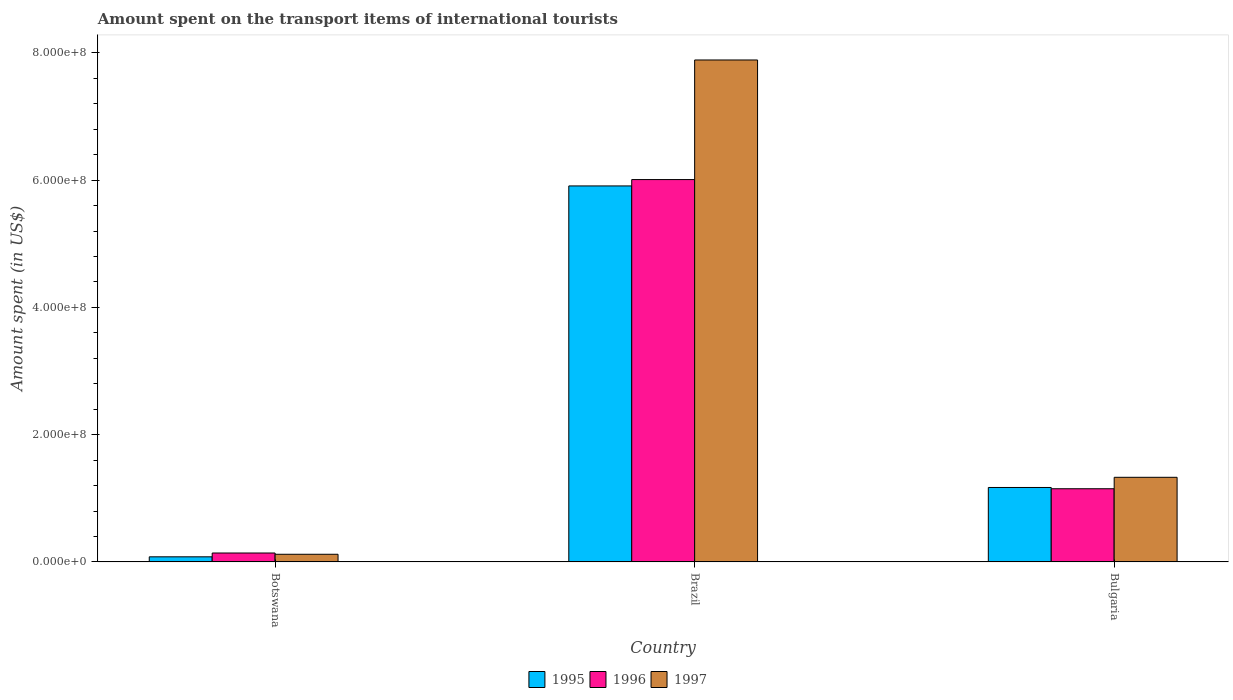How many groups of bars are there?
Offer a terse response. 3. Are the number of bars on each tick of the X-axis equal?
Offer a very short reply. Yes. What is the label of the 2nd group of bars from the left?
Give a very brief answer. Brazil. What is the amount spent on the transport items of international tourists in 1995 in Bulgaria?
Your response must be concise. 1.17e+08. Across all countries, what is the maximum amount spent on the transport items of international tourists in 1995?
Make the answer very short. 5.91e+08. In which country was the amount spent on the transport items of international tourists in 1995 maximum?
Offer a very short reply. Brazil. In which country was the amount spent on the transport items of international tourists in 1996 minimum?
Ensure brevity in your answer.  Botswana. What is the total amount spent on the transport items of international tourists in 1996 in the graph?
Your answer should be very brief. 7.30e+08. What is the difference between the amount spent on the transport items of international tourists in 1997 in Botswana and that in Brazil?
Provide a short and direct response. -7.77e+08. What is the difference between the amount spent on the transport items of international tourists in 1996 in Botswana and the amount spent on the transport items of international tourists in 1997 in Brazil?
Your answer should be very brief. -7.75e+08. What is the average amount spent on the transport items of international tourists in 1995 per country?
Provide a succinct answer. 2.39e+08. What is the difference between the amount spent on the transport items of international tourists of/in 1995 and amount spent on the transport items of international tourists of/in 1997 in Bulgaria?
Provide a short and direct response. -1.60e+07. In how many countries, is the amount spent on the transport items of international tourists in 1997 greater than 520000000 US$?
Your answer should be very brief. 1. What is the ratio of the amount spent on the transport items of international tourists in 1997 in Brazil to that in Bulgaria?
Provide a short and direct response. 5.93. Is the amount spent on the transport items of international tourists in 1996 in Botswana less than that in Bulgaria?
Make the answer very short. Yes. Is the difference between the amount spent on the transport items of international tourists in 1995 in Botswana and Bulgaria greater than the difference between the amount spent on the transport items of international tourists in 1997 in Botswana and Bulgaria?
Give a very brief answer. Yes. What is the difference between the highest and the second highest amount spent on the transport items of international tourists in 1995?
Your answer should be compact. 5.83e+08. What is the difference between the highest and the lowest amount spent on the transport items of international tourists in 1997?
Your answer should be very brief. 7.77e+08. What does the 1st bar from the right in Botswana represents?
Provide a short and direct response. 1997. How many bars are there?
Ensure brevity in your answer.  9. Are all the bars in the graph horizontal?
Provide a short and direct response. No. How many countries are there in the graph?
Your answer should be very brief. 3. What is the difference between two consecutive major ticks on the Y-axis?
Offer a very short reply. 2.00e+08. Are the values on the major ticks of Y-axis written in scientific E-notation?
Make the answer very short. Yes. How many legend labels are there?
Your answer should be very brief. 3. How are the legend labels stacked?
Make the answer very short. Horizontal. What is the title of the graph?
Keep it short and to the point. Amount spent on the transport items of international tourists. What is the label or title of the X-axis?
Your answer should be very brief. Country. What is the label or title of the Y-axis?
Your response must be concise. Amount spent (in US$). What is the Amount spent (in US$) in 1995 in Botswana?
Ensure brevity in your answer.  8.00e+06. What is the Amount spent (in US$) in 1996 in Botswana?
Your response must be concise. 1.40e+07. What is the Amount spent (in US$) in 1995 in Brazil?
Offer a terse response. 5.91e+08. What is the Amount spent (in US$) of 1996 in Brazil?
Ensure brevity in your answer.  6.01e+08. What is the Amount spent (in US$) in 1997 in Brazil?
Your answer should be compact. 7.89e+08. What is the Amount spent (in US$) in 1995 in Bulgaria?
Ensure brevity in your answer.  1.17e+08. What is the Amount spent (in US$) in 1996 in Bulgaria?
Make the answer very short. 1.15e+08. What is the Amount spent (in US$) in 1997 in Bulgaria?
Your answer should be compact. 1.33e+08. Across all countries, what is the maximum Amount spent (in US$) of 1995?
Give a very brief answer. 5.91e+08. Across all countries, what is the maximum Amount spent (in US$) of 1996?
Keep it short and to the point. 6.01e+08. Across all countries, what is the maximum Amount spent (in US$) of 1997?
Keep it short and to the point. 7.89e+08. Across all countries, what is the minimum Amount spent (in US$) in 1995?
Make the answer very short. 8.00e+06. Across all countries, what is the minimum Amount spent (in US$) of 1996?
Provide a succinct answer. 1.40e+07. Across all countries, what is the minimum Amount spent (in US$) in 1997?
Keep it short and to the point. 1.20e+07. What is the total Amount spent (in US$) of 1995 in the graph?
Your answer should be very brief. 7.16e+08. What is the total Amount spent (in US$) in 1996 in the graph?
Your response must be concise. 7.30e+08. What is the total Amount spent (in US$) of 1997 in the graph?
Provide a short and direct response. 9.34e+08. What is the difference between the Amount spent (in US$) in 1995 in Botswana and that in Brazil?
Provide a short and direct response. -5.83e+08. What is the difference between the Amount spent (in US$) of 1996 in Botswana and that in Brazil?
Give a very brief answer. -5.87e+08. What is the difference between the Amount spent (in US$) of 1997 in Botswana and that in Brazil?
Your answer should be very brief. -7.77e+08. What is the difference between the Amount spent (in US$) of 1995 in Botswana and that in Bulgaria?
Offer a terse response. -1.09e+08. What is the difference between the Amount spent (in US$) in 1996 in Botswana and that in Bulgaria?
Make the answer very short. -1.01e+08. What is the difference between the Amount spent (in US$) in 1997 in Botswana and that in Bulgaria?
Provide a succinct answer. -1.21e+08. What is the difference between the Amount spent (in US$) of 1995 in Brazil and that in Bulgaria?
Offer a very short reply. 4.74e+08. What is the difference between the Amount spent (in US$) of 1996 in Brazil and that in Bulgaria?
Offer a terse response. 4.86e+08. What is the difference between the Amount spent (in US$) in 1997 in Brazil and that in Bulgaria?
Offer a terse response. 6.56e+08. What is the difference between the Amount spent (in US$) in 1995 in Botswana and the Amount spent (in US$) in 1996 in Brazil?
Your answer should be very brief. -5.93e+08. What is the difference between the Amount spent (in US$) of 1995 in Botswana and the Amount spent (in US$) of 1997 in Brazil?
Give a very brief answer. -7.81e+08. What is the difference between the Amount spent (in US$) in 1996 in Botswana and the Amount spent (in US$) in 1997 in Brazil?
Provide a short and direct response. -7.75e+08. What is the difference between the Amount spent (in US$) of 1995 in Botswana and the Amount spent (in US$) of 1996 in Bulgaria?
Your answer should be compact. -1.07e+08. What is the difference between the Amount spent (in US$) of 1995 in Botswana and the Amount spent (in US$) of 1997 in Bulgaria?
Your answer should be compact. -1.25e+08. What is the difference between the Amount spent (in US$) in 1996 in Botswana and the Amount spent (in US$) in 1997 in Bulgaria?
Give a very brief answer. -1.19e+08. What is the difference between the Amount spent (in US$) of 1995 in Brazil and the Amount spent (in US$) of 1996 in Bulgaria?
Your answer should be compact. 4.76e+08. What is the difference between the Amount spent (in US$) in 1995 in Brazil and the Amount spent (in US$) in 1997 in Bulgaria?
Ensure brevity in your answer.  4.58e+08. What is the difference between the Amount spent (in US$) in 1996 in Brazil and the Amount spent (in US$) in 1997 in Bulgaria?
Give a very brief answer. 4.68e+08. What is the average Amount spent (in US$) in 1995 per country?
Offer a terse response. 2.39e+08. What is the average Amount spent (in US$) of 1996 per country?
Your response must be concise. 2.43e+08. What is the average Amount spent (in US$) of 1997 per country?
Give a very brief answer. 3.11e+08. What is the difference between the Amount spent (in US$) of 1995 and Amount spent (in US$) of 1996 in Botswana?
Make the answer very short. -6.00e+06. What is the difference between the Amount spent (in US$) of 1995 and Amount spent (in US$) of 1997 in Botswana?
Your answer should be very brief. -4.00e+06. What is the difference between the Amount spent (in US$) in 1996 and Amount spent (in US$) in 1997 in Botswana?
Your answer should be very brief. 2.00e+06. What is the difference between the Amount spent (in US$) of 1995 and Amount spent (in US$) of 1996 in Brazil?
Provide a short and direct response. -1.00e+07. What is the difference between the Amount spent (in US$) of 1995 and Amount spent (in US$) of 1997 in Brazil?
Offer a very short reply. -1.98e+08. What is the difference between the Amount spent (in US$) in 1996 and Amount spent (in US$) in 1997 in Brazil?
Offer a terse response. -1.88e+08. What is the difference between the Amount spent (in US$) of 1995 and Amount spent (in US$) of 1996 in Bulgaria?
Offer a terse response. 2.00e+06. What is the difference between the Amount spent (in US$) of 1995 and Amount spent (in US$) of 1997 in Bulgaria?
Your answer should be very brief. -1.60e+07. What is the difference between the Amount spent (in US$) in 1996 and Amount spent (in US$) in 1997 in Bulgaria?
Offer a terse response. -1.80e+07. What is the ratio of the Amount spent (in US$) of 1995 in Botswana to that in Brazil?
Ensure brevity in your answer.  0.01. What is the ratio of the Amount spent (in US$) of 1996 in Botswana to that in Brazil?
Provide a succinct answer. 0.02. What is the ratio of the Amount spent (in US$) in 1997 in Botswana to that in Brazil?
Your answer should be very brief. 0.02. What is the ratio of the Amount spent (in US$) of 1995 in Botswana to that in Bulgaria?
Offer a terse response. 0.07. What is the ratio of the Amount spent (in US$) of 1996 in Botswana to that in Bulgaria?
Provide a succinct answer. 0.12. What is the ratio of the Amount spent (in US$) in 1997 in Botswana to that in Bulgaria?
Your response must be concise. 0.09. What is the ratio of the Amount spent (in US$) in 1995 in Brazil to that in Bulgaria?
Offer a terse response. 5.05. What is the ratio of the Amount spent (in US$) of 1996 in Brazil to that in Bulgaria?
Give a very brief answer. 5.23. What is the ratio of the Amount spent (in US$) in 1997 in Brazil to that in Bulgaria?
Offer a very short reply. 5.93. What is the difference between the highest and the second highest Amount spent (in US$) of 1995?
Make the answer very short. 4.74e+08. What is the difference between the highest and the second highest Amount spent (in US$) of 1996?
Ensure brevity in your answer.  4.86e+08. What is the difference between the highest and the second highest Amount spent (in US$) of 1997?
Your answer should be compact. 6.56e+08. What is the difference between the highest and the lowest Amount spent (in US$) of 1995?
Your answer should be compact. 5.83e+08. What is the difference between the highest and the lowest Amount spent (in US$) in 1996?
Offer a terse response. 5.87e+08. What is the difference between the highest and the lowest Amount spent (in US$) in 1997?
Ensure brevity in your answer.  7.77e+08. 